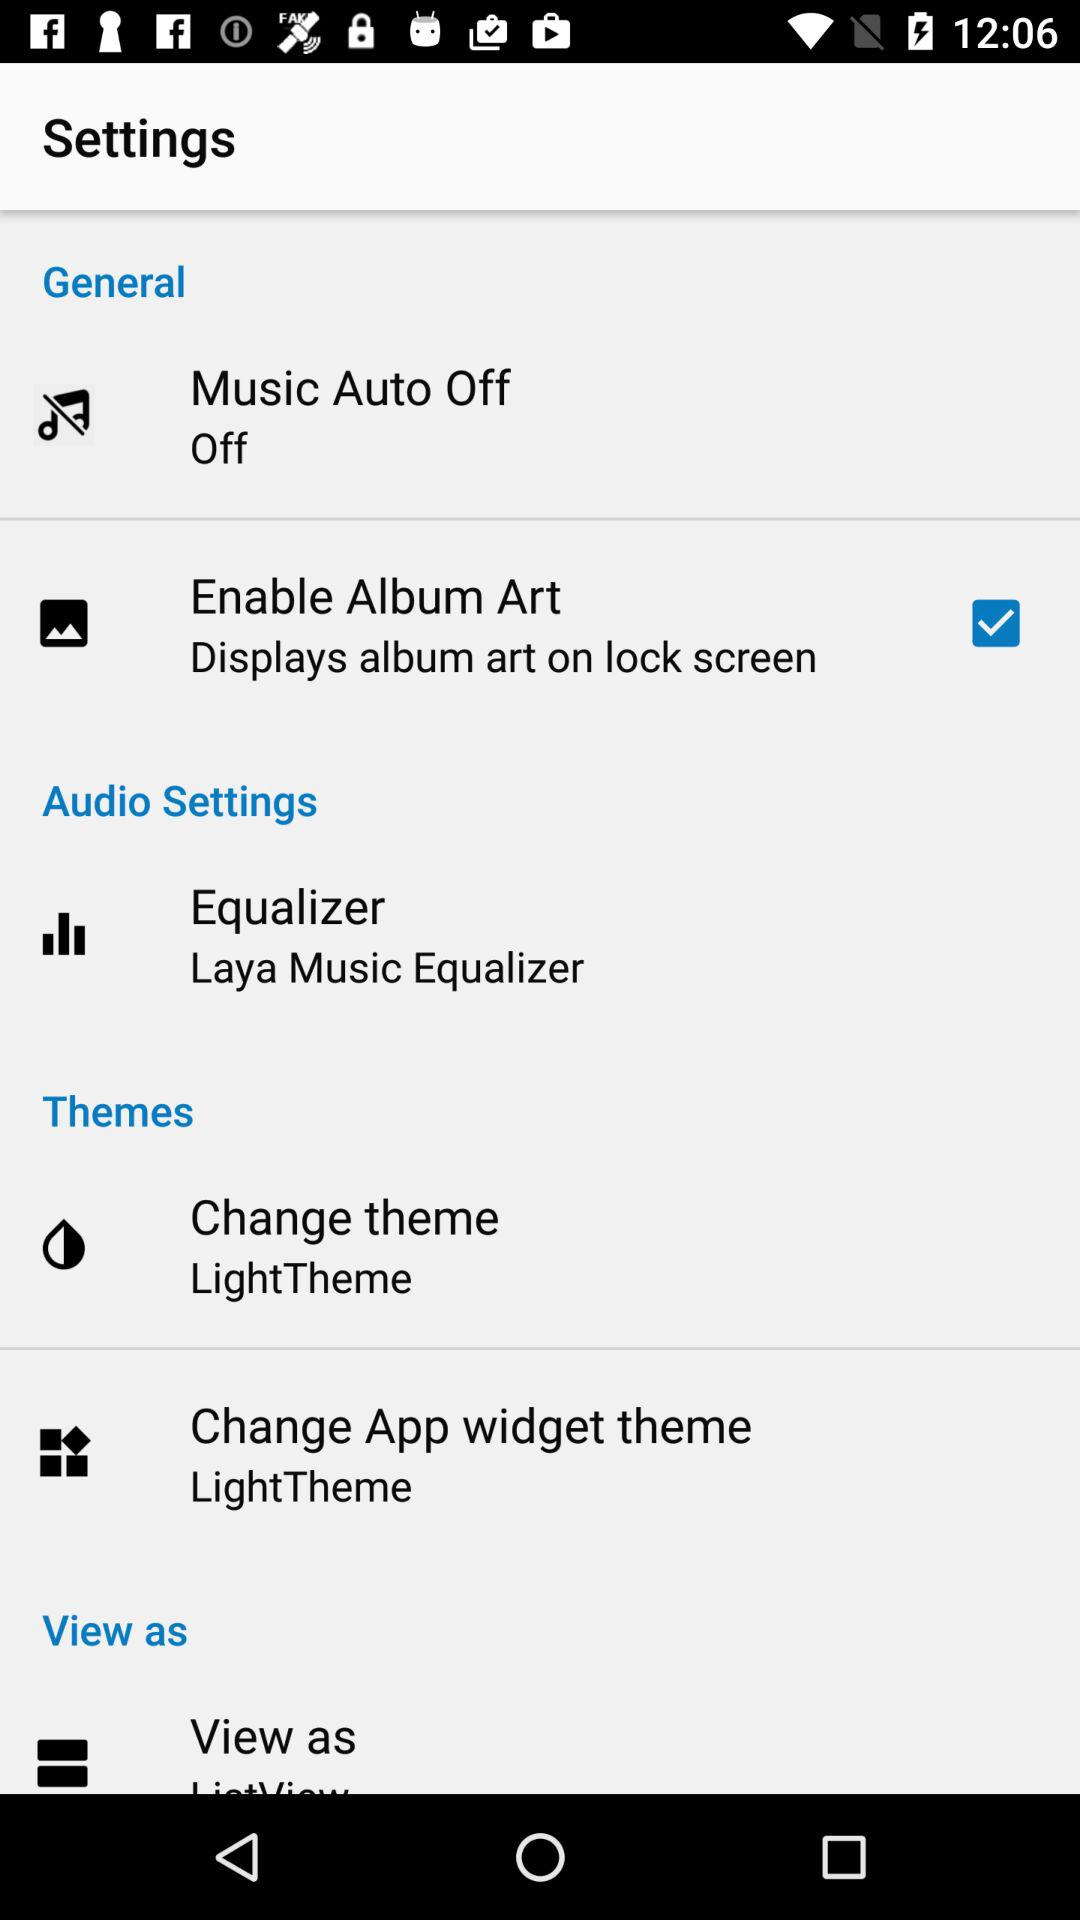What is the status of the "Enable Album Art"? The status is "on". 